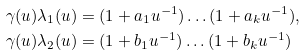<formula> <loc_0><loc_0><loc_500><loc_500>\gamma ( u ) \lambda _ { 1 } ( u ) & = ( 1 + a _ { 1 } u ^ { - 1 } ) \dots ( 1 + a _ { k } u ^ { - 1 } ) , \\ \gamma ( u ) \lambda _ { 2 } ( u ) & = ( 1 + b _ { 1 } u ^ { - 1 } ) \dots ( 1 + b _ { k } u ^ { - 1 } )</formula> 